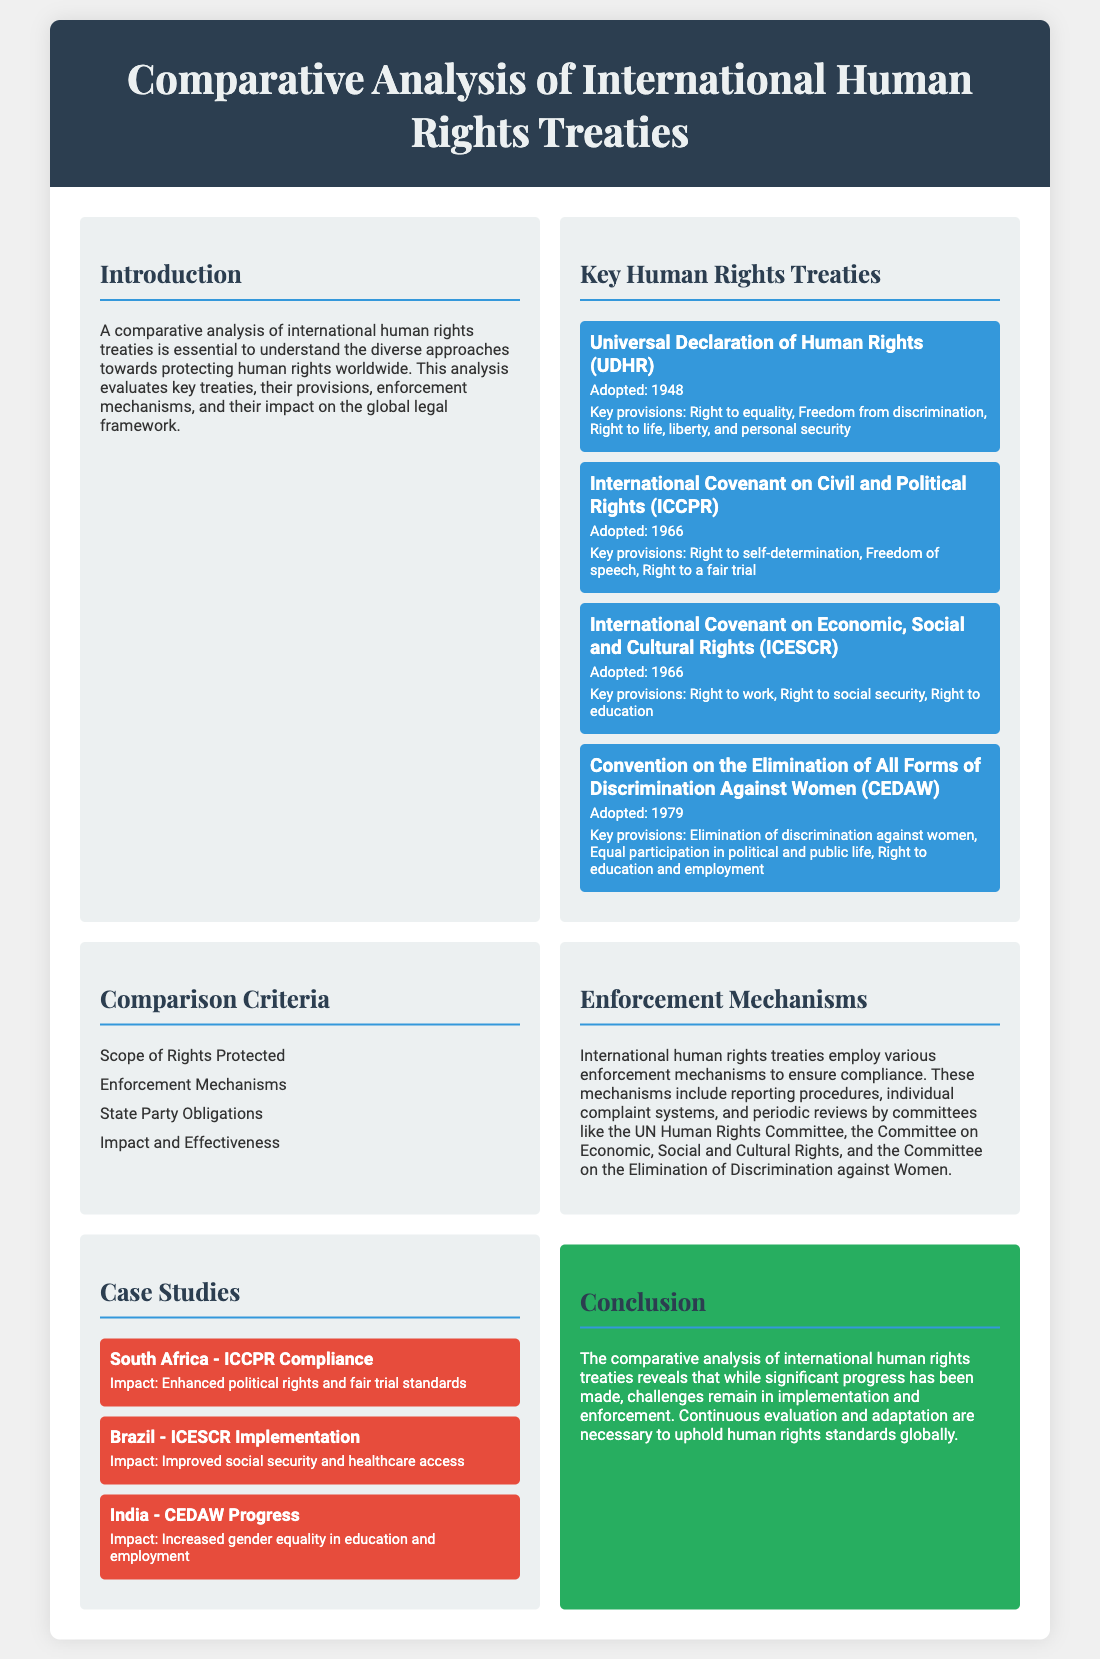What year was the Universal Declaration of Human Rights adopted? The document states that the Universal Declaration of Human Rights was adopted in 1948.
Answer: 1948 What are the key provisions of the ICCPR? The document lists the key provisions of the ICCPR as the right to self-determination, freedom of speech, and the right to a fair trial.
Answer: Right to self-determination, freedom of speech, right to a fair trial What is one enforcement mechanism used by international human rights treaties? The document mentions several enforcement mechanisms, one of which is reporting procedures.
Answer: Reporting procedures How many case studies are presented in the poster? The document outlines three case studies related to compliance and implementation of treaties in different countries.
Answer: Three Which treaty emphasizes the elimination of discrimination against women? The document specifies that the Convention on the Elimination of All Forms of Discrimination Against Women (CEDAW) focuses on this issue.
Answer: CEDAW What impact did the ICCPR have in South Africa according to the case study? The document indicates that the impact was enhanced political rights and fair trial standards.
Answer: Enhanced political rights and fair trial standards What is the conclusion about the progress of human rights treaties? The document concludes that while progress has been made, challenges remain in implementation and enforcement.
Answer: Challenges remain in implementation and enforcement What criterion relates to "State Party Obligations"? The document lists "State Party Obligations" as one of the comparison criteria for treaties.
Answer: State Party Obligations 